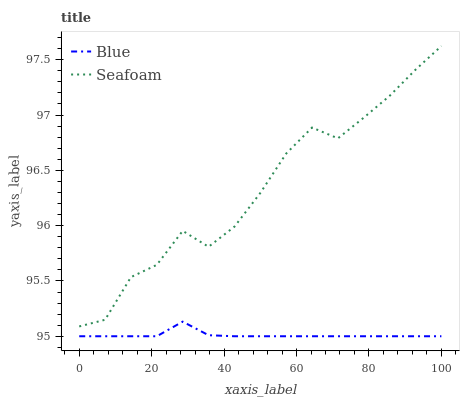Does Blue have the minimum area under the curve?
Answer yes or no. Yes. Does Seafoam have the maximum area under the curve?
Answer yes or no. Yes. Does Seafoam have the minimum area under the curve?
Answer yes or no. No. Is Blue the smoothest?
Answer yes or no. Yes. Is Seafoam the roughest?
Answer yes or no. Yes. Is Seafoam the smoothest?
Answer yes or no. No. Does Blue have the lowest value?
Answer yes or no. Yes. Does Seafoam have the lowest value?
Answer yes or no. No. Does Seafoam have the highest value?
Answer yes or no. Yes. Is Blue less than Seafoam?
Answer yes or no. Yes. Is Seafoam greater than Blue?
Answer yes or no. Yes. Does Blue intersect Seafoam?
Answer yes or no. No. 